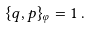Convert formula to latex. <formula><loc_0><loc_0><loc_500><loc_500>\{ q , p \} _ { \varphi } = 1 \, .</formula> 